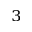Convert formula to latex. <formula><loc_0><loc_0><loc_500><loc_500>^ { 3 }</formula> 